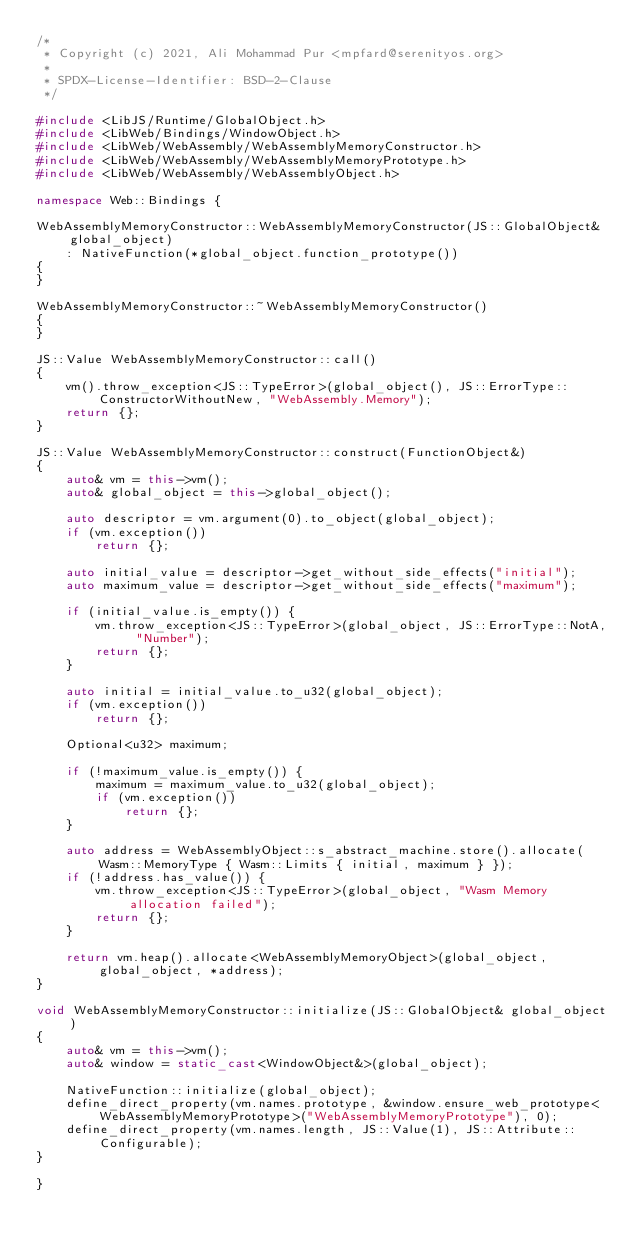<code> <loc_0><loc_0><loc_500><loc_500><_C++_>/*
 * Copyright (c) 2021, Ali Mohammad Pur <mpfard@serenityos.org>
 *
 * SPDX-License-Identifier: BSD-2-Clause
 */

#include <LibJS/Runtime/GlobalObject.h>
#include <LibWeb/Bindings/WindowObject.h>
#include <LibWeb/WebAssembly/WebAssemblyMemoryConstructor.h>
#include <LibWeb/WebAssembly/WebAssemblyMemoryPrototype.h>
#include <LibWeb/WebAssembly/WebAssemblyObject.h>

namespace Web::Bindings {

WebAssemblyMemoryConstructor::WebAssemblyMemoryConstructor(JS::GlobalObject& global_object)
    : NativeFunction(*global_object.function_prototype())
{
}

WebAssemblyMemoryConstructor::~WebAssemblyMemoryConstructor()
{
}

JS::Value WebAssemblyMemoryConstructor::call()
{
    vm().throw_exception<JS::TypeError>(global_object(), JS::ErrorType::ConstructorWithoutNew, "WebAssembly.Memory");
    return {};
}

JS::Value WebAssemblyMemoryConstructor::construct(FunctionObject&)
{
    auto& vm = this->vm();
    auto& global_object = this->global_object();

    auto descriptor = vm.argument(0).to_object(global_object);
    if (vm.exception())
        return {};

    auto initial_value = descriptor->get_without_side_effects("initial");
    auto maximum_value = descriptor->get_without_side_effects("maximum");

    if (initial_value.is_empty()) {
        vm.throw_exception<JS::TypeError>(global_object, JS::ErrorType::NotA, "Number");
        return {};
    }

    auto initial = initial_value.to_u32(global_object);
    if (vm.exception())
        return {};

    Optional<u32> maximum;

    if (!maximum_value.is_empty()) {
        maximum = maximum_value.to_u32(global_object);
        if (vm.exception())
            return {};
    }

    auto address = WebAssemblyObject::s_abstract_machine.store().allocate(Wasm::MemoryType { Wasm::Limits { initial, maximum } });
    if (!address.has_value()) {
        vm.throw_exception<JS::TypeError>(global_object, "Wasm Memory allocation failed");
        return {};
    }

    return vm.heap().allocate<WebAssemblyMemoryObject>(global_object, global_object, *address);
}

void WebAssemblyMemoryConstructor::initialize(JS::GlobalObject& global_object)
{
    auto& vm = this->vm();
    auto& window = static_cast<WindowObject&>(global_object);

    NativeFunction::initialize(global_object);
    define_direct_property(vm.names.prototype, &window.ensure_web_prototype<WebAssemblyMemoryPrototype>("WebAssemblyMemoryPrototype"), 0);
    define_direct_property(vm.names.length, JS::Value(1), JS::Attribute::Configurable);
}

}
</code> 